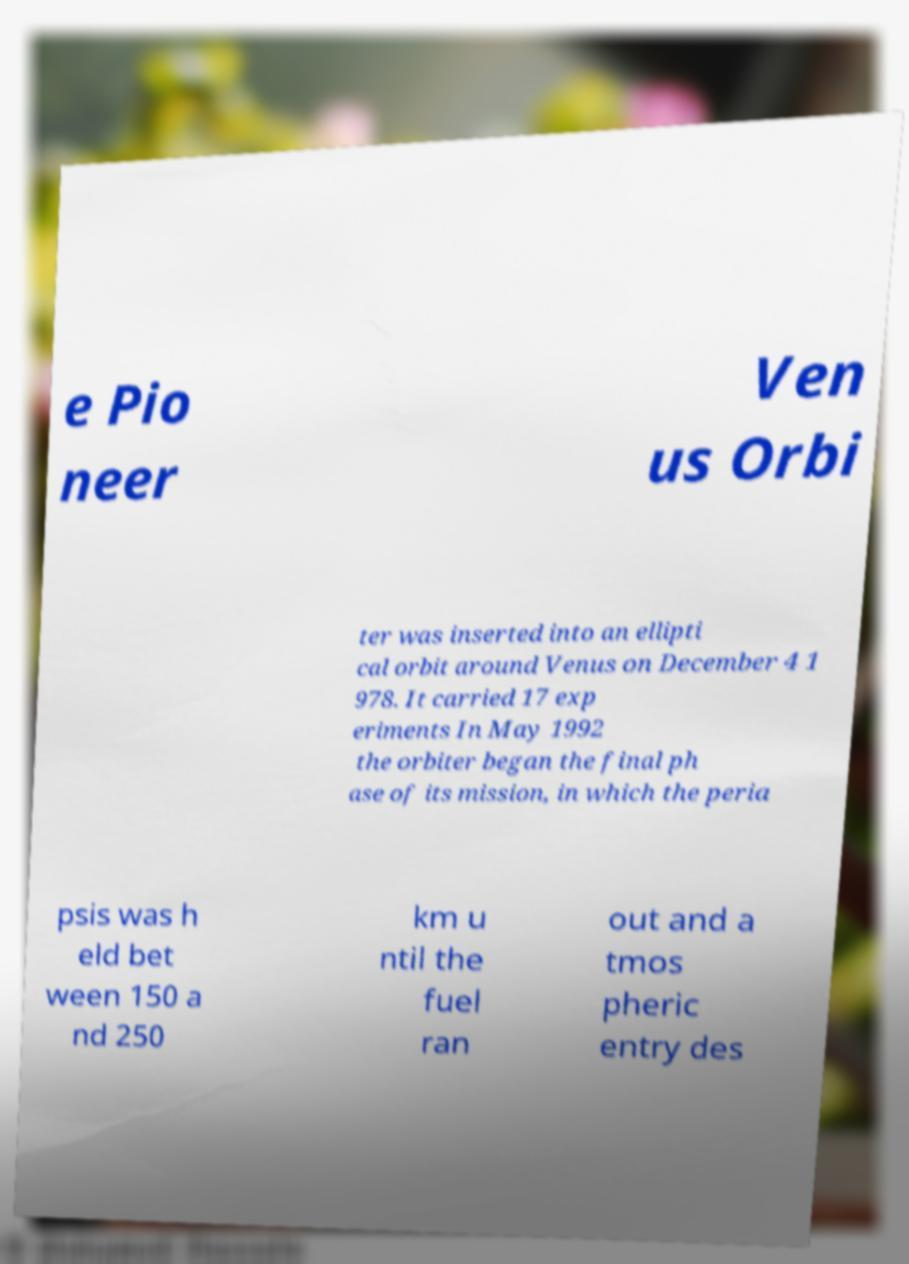Please read and relay the text visible in this image. What does it say? e Pio neer Ven us Orbi ter was inserted into an ellipti cal orbit around Venus on December 4 1 978. It carried 17 exp eriments In May 1992 the orbiter began the final ph ase of its mission, in which the peria psis was h eld bet ween 150 a nd 250 km u ntil the fuel ran out and a tmos pheric entry des 